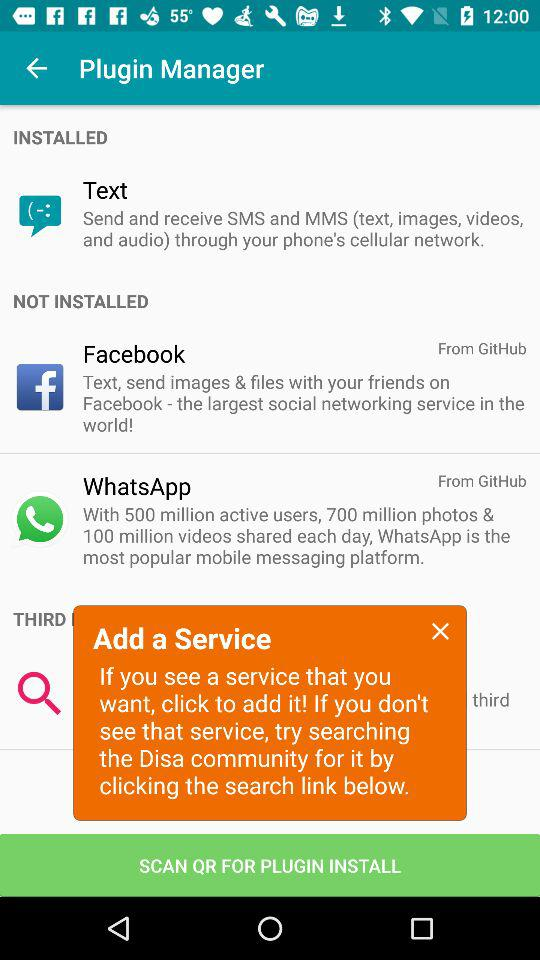Which applications are not installed? The applications are "Facebook" and "WhatsApp". 